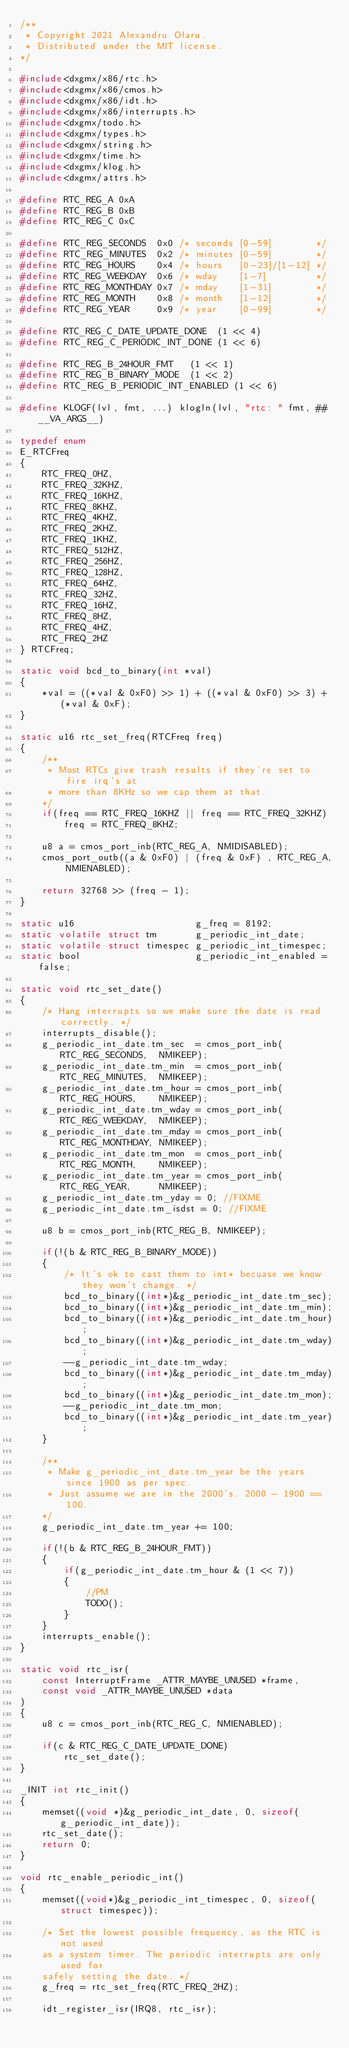<code> <loc_0><loc_0><loc_500><loc_500><_C_>/**
 * Copyright 2021 Alexandru Olaru.
 * Distributed under the MIT license.
*/

#include<dxgmx/x86/rtc.h>
#include<dxgmx/x86/cmos.h>
#include<dxgmx/x86/idt.h>
#include<dxgmx/x86/interrupts.h>
#include<dxgmx/todo.h>
#include<dxgmx/types.h>
#include<dxgmx/string.h>
#include<dxgmx/time.h>
#include<dxgmx/klog.h>
#include<dxgmx/attrs.h>

#define RTC_REG_A 0xA
#define RTC_REG_B 0xB
#define RTC_REG_C 0xC

#define RTC_REG_SECONDS  0x0 /* seconds [0-59]        */
#define RTC_REG_MINUTES  0x2 /* minutes [0-59]        */
#define RTC_REG_HOURS    0x4 /* hours   [0-23]/[1-12] */
#define RTC_REG_WEEKDAY  0x6 /* wday    [1-7]         */
#define RTC_REG_MONTHDAY 0x7 /* mday    [1-31]        */
#define RTC_REG_MONTH    0x8 /* month   [1-12]        */
#define RTC_REG_YEAR     0x9 /* year    [0-99]        */

#define RTC_REG_C_DATE_UPDATE_DONE  (1 << 4)
#define RTC_REG_C_PERIODIC_INT_DONE (1 << 6)

#define RTC_REG_B_24HOUR_FMT   (1 << 1)
#define RTC_REG_B_BINARY_MODE  (1 << 2)
#define RTC_REG_B_PERIODIC_INT_ENABLED (1 << 6)

#define KLOGF(lvl, fmt, ...) klogln(lvl, "rtc: " fmt, ##__VA_ARGS__)

typedef enum
E_RTCFreq
{
    RTC_FREQ_0HZ,
    RTC_FREQ_32KHZ,
    RTC_FREQ_16KHZ,
    RTC_FREQ_8KHZ,
    RTC_FREQ_4KHZ, 
    RTC_FREQ_2KHZ,
    RTC_FREQ_1KHZ,
    RTC_FREQ_512HZ,
    RTC_FREQ_256HZ,
    RTC_FREQ_128HZ,
    RTC_FREQ_64HZ,
    RTC_FREQ_32HZ,
    RTC_FREQ_16HZ,
    RTC_FREQ_8HZ,
    RTC_FREQ_4HZ,
    RTC_FREQ_2HZ
} RTCFreq;

static void bcd_to_binary(int *val)
{
    *val = ((*val & 0xF0) >> 1) + ((*val & 0xF0) >> 3) + (*val & 0xF);
}

static u16 rtc_set_freq(RTCFreq freq)
{
    /**
     * Most RTCs give trash results if they're set to fire irq's at
     * more than 8KHz so we cap them at that. 
    */
    if(freq == RTC_FREQ_16KHZ || freq == RTC_FREQ_32KHZ)
        freq = RTC_FREQ_8KHZ;

    u8 a = cmos_port_inb(RTC_REG_A, NMIDISABLED);
    cmos_port_outb((a & 0xF0) | (freq & 0xF) , RTC_REG_A, NMIENABLED);

    return 32768 >> (freq - 1);
}

static u16                      g_freq = 8192;
static volatile struct tm       g_periodic_int_date;
static volatile struct timespec g_periodic_int_timespec;
static bool                     g_periodic_int_enabled = false;

static void rtc_set_date()
{
    /* Hang interrupts so we make sure the date is read correctly. */
    interrupts_disable();
    g_periodic_int_date.tm_sec  = cmos_port_inb(RTC_REG_SECONDS,  NMIKEEP);
    g_periodic_int_date.tm_min  = cmos_port_inb(RTC_REG_MINUTES,  NMIKEEP);
    g_periodic_int_date.tm_hour = cmos_port_inb(RTC_REG_HOURS,    NMIKEEP);
    g_periodic_int_date.tm_wday = cmos_port_inb(RTC_REG_WEEKDAY,  NMIKEEP);
    g_periodic_int_date.tm_mday = cmos_port_inb(RTC_REG_MONTHDAY, NMIKEEP);
    g_periodic_int_date.tm_mon  = cmos_port_inb(RTC_REG_MONTH,    NMIKEEP);
    g_periodic_int_date.tm_year = cmos_port_inb(RTC_REG_YEAR,     NMIKEEP);
    g_periodic_int_date.tm_yday = 0; //FIXME
    g_periodic_int_date.tm_isdst = 0; //FIXME

    u8 b = cmos_port_inb(RTC_REG_B, NMIKEEP);

    if(!(b & RTC_REG_B_BINARY_MODE))
    {
        /* It's ok to cast them to int* becuase we know they won't change. */
        bcd_to_binary((int*)&g_periodic_int_date.tm_sec);
        bcd_to_binary((int*)&g_periodic_int_date.tm_min);
        bcd_to_binary((int*)&g_periodic_int_date.tm_hour);
        bcd_to_binary((int*)&g_periodic_int_date.tm_wday);
        --g_periodic_int_date.tm_wday;
        bcd_to_binary((int*)&g_periodic_int_date.tm_mday);
        bcd_to_binary((int*)&g_periodic_int_date.tm_mon);
        --g_periodic_int_date.tm_mon;
        bcd_to_binary((int*)&g_periodic_int_date.tm_year);
    }

    /** 
     * Make g_periodic_int_date.tm_year be the years since 1900 as per spec. 
     * Just assume we are in the 2000's. 2000 - 1900 == 100.
    */
    g_periodic_int_date.tm_year += 100;

    if(!(b & RTC_REG_B_24HOUR_FMT))
    {
        if(g_periodic_int_date.tm_hour & (1 << 7))
        {
            //PM
            TODO();
        }
    }
    interrupts_enable();
}

static void rtc_isr(
    const InterruptFrame _ATTR_MAYBE_UNUSED *frame, 
    const void _ATTR_MAYBE_UNUSED *data
)
{
    u8 c = cmos_port_inb(RTC_REG_C, NMIENABLED);

    if(c & RTC_REG_C_DATE_UPDATE_DONE)
        rtc_set_date();
}

_INIT int rtc_init()
{
    memset((void *)&g_periodic_int_date, 0, sizeof(g_periodic_int_date));
    rtc_set_date();
    return 0;
}

void rtc_enable_periodic_int()
{
    memset((void*)&g_periodic_int_timespec, 0, sizeof(struct timespec));

    /* Set the lowest possible frequency, as the RTC is not used
    as a system timer. The periodic interrupts are only used for
    safely setting the date. */
    g_freq = rtc_set_freq(RTC_FREQ_2HZ);

    idt_register_isr(IRQ8, rtc_isr);
</code> 